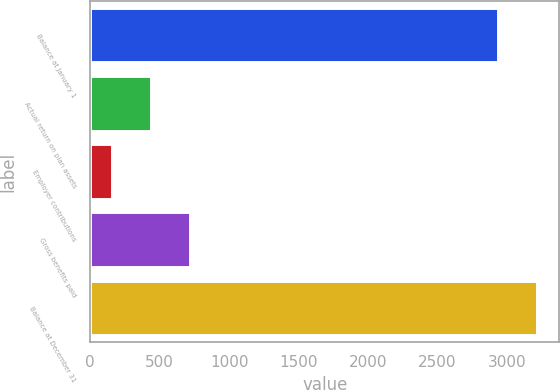Convert chart. <chart><loc_0><loc_0><loc_500><loc_500><bar_chart><fcel>Balance at January 1<fcel>Actual return on plan assets<fcel>Employer contributions<fcel>Gross benefits paid<fcel>Balance at December 31<nl><fcel>2934<fcel>440.9<fcel>160<fcel>721.8<fcel>3214.9<nl></chart> 